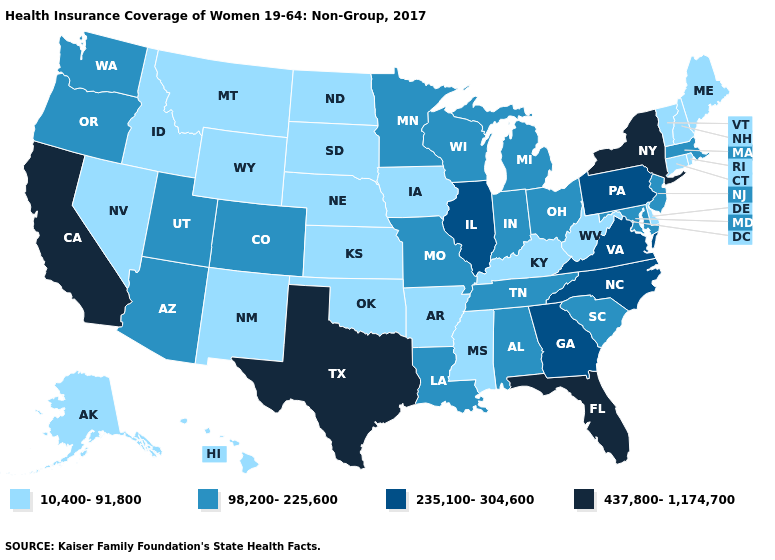Which states hav the highest value in the Northeast?
Write a very short answer. New York. Does Kansas have the same value as Delaware?
Write a very short answer. Yes. Name the states that have a value in the range 437,800-1,174,700?
Concise answer only. California, Florida, New York, Texas. What is the value of New Jersey?
Write a very short answer. 98,200-225,600. Among the states that border Arkansas , which have the lowest value?
Concise answer only. Mississippi, Oklahoma. Does Arkansas have the highest value in the South?
Quick response, please. No. Name the states that have a value in the range 98,200-225,600?
Write a very short answer. Alabama, Arizona, Colorado, Indiana, Louisiana, Maryland, Massachusetts, Michigan, Minnesota, Missouri, New Jersey, Ohio, Oregon, South Carolina, Tennessee, Utah, Washington, Wisconsin. Does the first symbol in the legend represent the smallest category?
Give a very brief answer. Yes. Name the states that have a value in the range 235,100-304,600?
Keep it brief. Georgia, Illinois, North Carolina, Pennsylvania, Virginia. Does Kansas have the lowest value in the USA?
Give a very brief answer. Yes. Does Kansas have the lowest value in the USA?
Short answer required. Yes. Name the states that have a value in the range 10,400-91,800?
Keep it brief. Alaska, Arkansas, Connecticut, Delaware, Hawaii, Idaho, Iowa, Kansas, Kentucky, Maine, Mississippi, Montana, Nebraska, Nevada, New Hampshire, New Mexico, North Dakota, Oklahoma, Rhode Island, South Dakota, Vermont, West Virginia, Wyoming. Which states hav the highest value in the South?
Short answer required. Florida, Texas. Does Illinois have the highest value in the MidWest?
Answer briefly. Yes. Name the states that have a value in the range 235,100-304,600?
Be succinct. Georgia, Illinois, North Carolina, Pennsylvania, Virginia. 